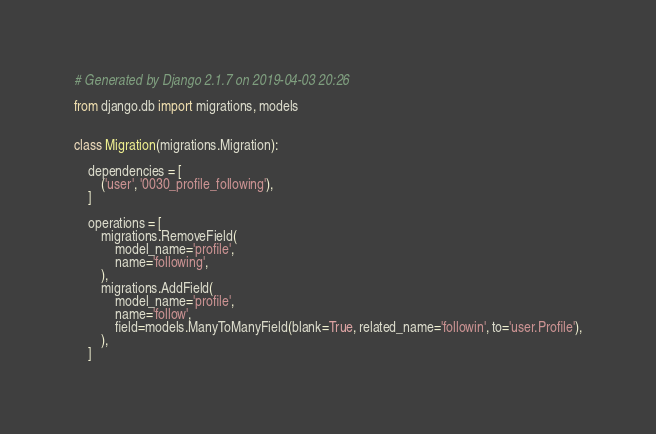Convert code to text. <code><loc_0><loc_0><loc_500><loc_500><_Python_># Generated by Django 2.1.7 on 2019-04-03 20:26

from django.db import migrations, models


class Migration(migrations.Migration):

    dependencies = [
        ('user', '0030_profile_following'),
    ]

    operations = [
        migrations.RemoveField(
            model_name='profile',
            name='following',
        ),
        migrations.AddField(
            model_name='profile',
            name='follow',
            field=models.ManyToManyField(blank=True, related_name='followin', to='user.Profile'),
        ),
    ]
</code> 